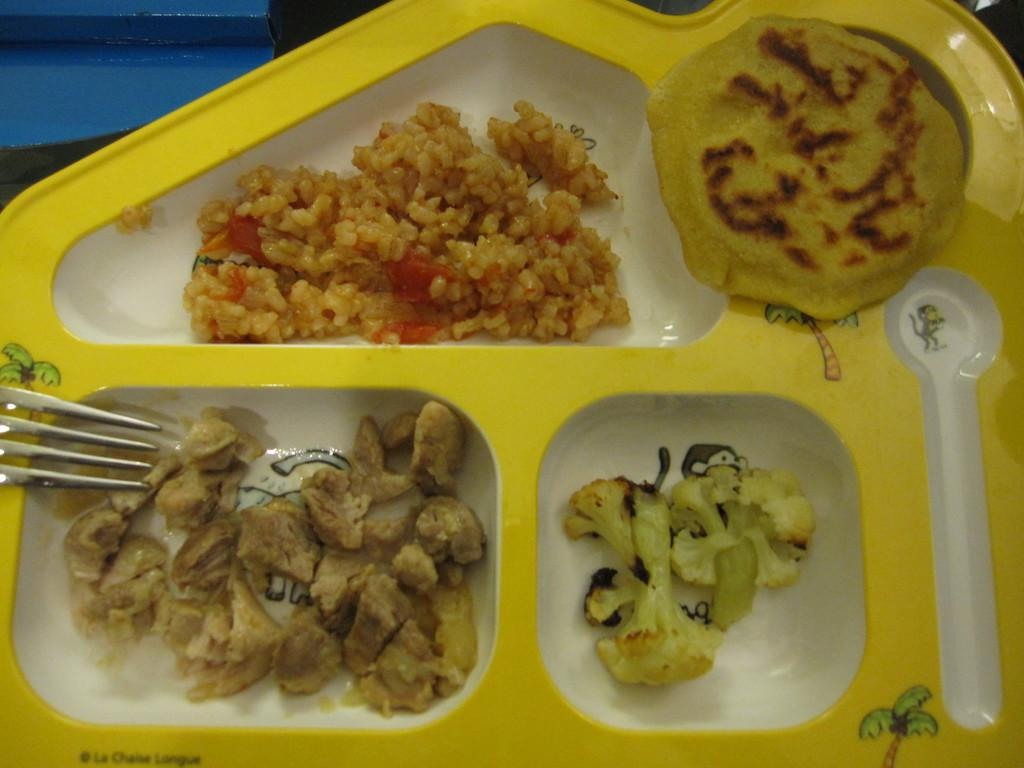What is on the plate in the image? There is food in a plate in the image. What utensil is visible in the image? There is a fork visible in the image. What type of ray is being offered in the class depicted in the image? There is no ray or class present in the image; it only shows food in a plate and a fork. 